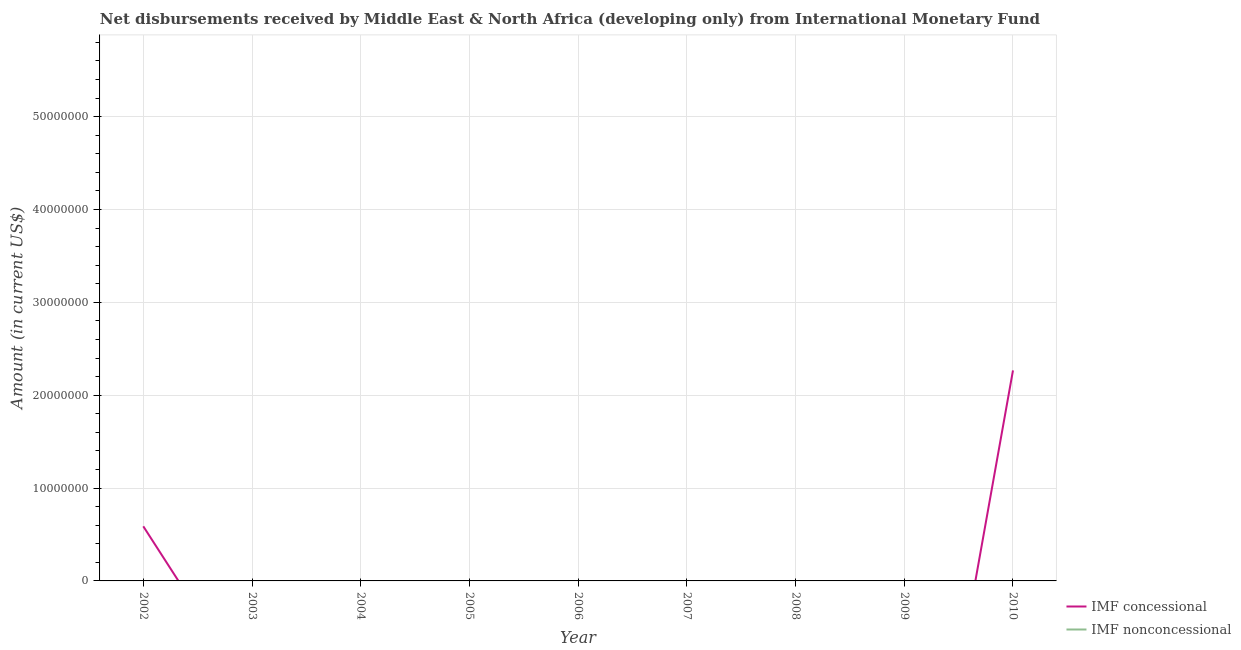How many different coloured lines are there?
Provide a succinct answer. 1. Does the line corresponding to net non concessional disbursements from imf intersect with the line corresponding to net concessional disbursements from imf?
Your response must be concise. Yes. Is the number of lines equal to the number of legend labels?
Provide a short and direct response. No. What is the net non concessional disbursements from imf in 2002?
Make the answer very short. 0. Across all years, what is the maximum net concessional disbursements from imf?
Keep it short and to the point. 2.27e+07. In which year was the net concessional disbursements from imf maximum?
Keep it short and to the point. 2010. What is the difference between the net non concessional disbursements from imf in 2009 and the net concessional disbursements from imf in 2008?
Offer a very short reply. 0. What is the average net concessional disbursements from imf per year?
Offer a terse response. 3.17e+06. What is the difference between the highest and the lowest net concessional disbursements from imf?
Provide a succinct answer. 2.27e+07. In how many years, is the net concessional disbursements from imf greater than the average net concessional disbursements from imf taken over all years?
Make the answer very short. 2. Does the net concessional disbursements from imf monotonically increase over the years?
Keep it short and to the point. No. Is the net concessional disbursements from imf strictly less than the net non concessional disbursements from imf over the years?
Ensure brevity in your answer.  No. How many years are there in the graph?
Offer a terse response. 9. What is the difference between two consecutive major ticks on the Y-axis?
Ensure brevity in your answer.  1.00e+07. How are the legend labels stacked?
Your response must be concise. Vertical. What is the title of the graph?
Give a very brief answer. Net disbursements received by Middle East & North Africa (developing only) from International Monetary Fund. What is the label or title of the X-axis?
Offer a very short reply. Year. What is the label or title of the Y-axis?
Give a very brief answer. Amount (in current US$). What is the Amount (in current US$) of IMF concessional in 2002?
Your response must be concise. 5.88e+06. What is the Amount (in current US$) in IMF concessional in 2003?
Ensure brevity in your answer.  0. What is the Amount (in current US$) in IMF concessional in 2006?
Make the answer very short. 0. What is the Amount (in current US$) in IMF nonconcessional in 2006?
Your answer should be very brief. 0. What is the Amount (in current US$) of IMF nonconcessional in 2007?
Your response must be concise. 0. What is the Amount (in current US$) of IMF nonconcessional in 2008?
Your response must be concise. 0. What is the Amount (in current US$) in IMF concessional in 2009?
Your answer should be very brief. 0. What is the Amount (in current US$) of IMF concessional in 2010?
Give a very brief answer. 2.27e+07. What is the Amount (in current US$) of IMF nonconcessional in 2010?
Provide a short and direct response. 0. Across all years, what is the maximum Amount (in current US$) in IMF concessional?
Offer a very short reply. 2.27e+07. Across all years, what is the minimum Amount (in current US$) in IMF concessional?
Give a very brief answer. 0. What is the total Amount (in current US$) of IMF concessional in the graph?
Your answer should be very brief. 2.86e+07. What is the difference between the Amount (in current US$) in IMF concessional in 2002 and that in 2010?
Provide a succinct answer. -1.68e+07. What is the average Amount (in current US$) of IMF concessional per year?
Offer a very short reply. 3.17e+06. What is the ratio of the Amount (in current US$) of IMF concessional in 2002 to that in 2010?
Offer a very short reply. 0.26. What is the difference between the highest and the lowest Amount (in current US$) in IMF concessional?
Keep it short and to the point. 2.27e+07. 